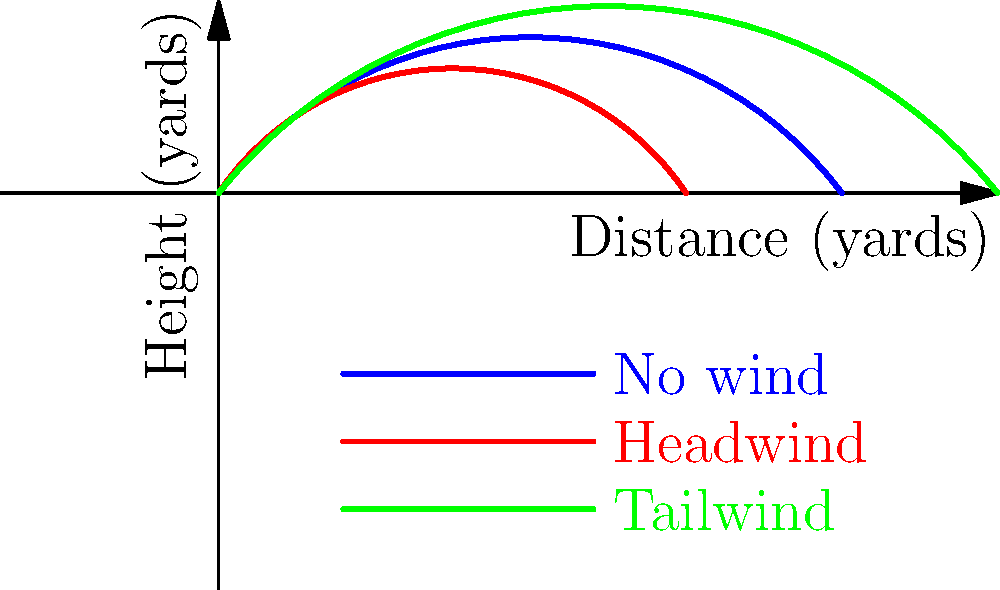In a football game, Coach Jess Simpson is discussing the impact of wind on passing plays. Based on the graph showing the flight paths of a football thrown under different wind conditions, which wind condition allows for the longest pass? To determine which wind condition allows for the longest pass, we need to analyze the flight paths shown in the graph:

1. The blue line represents the flight path with no wind.
2. The red line represents the flight path with a headwind.
3. The green line represents the flight path with a tailwind.

Let's examine each path:

1. No wind (blue line):
   - The pass travels approximately 40 yards.

2. Headwind (red line):
   - The pass travels approximately 30 yards.
   - The path is shorter and lower than the no-wind condition.

3. Tailwind (green line):
   - The pass travels approximately 50 yards.
   - The path is longer and higher than both the no-wind and headwind conditions.

By comparing these flight paths, we can see that the green line (tailwind) extends the farthest along the x-axis, reaching about 50 yards.

Therefore, the tailwind condition allows for the longest pass.
Answer: Tailwind 